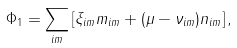<formula> <loc_0><loc_0><loc_500><loc_500>\Phi _ { 1 } = \sum _ { i m } \left [ \xi _ { i m } m _ { i m } + ( \mu - \nu _ { i m } ) n _ { i m } \right ] ,</formula> 